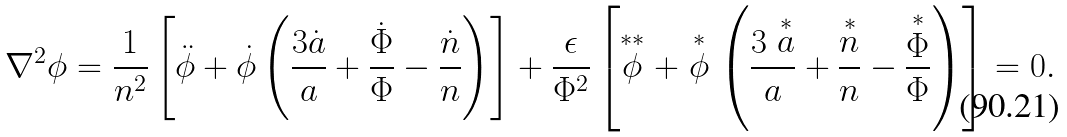Convert formula to latex. <formula><loc_0><loc_0><loc_500><loc_500>\nabla ^ { 2 } \phi = \frac { 1 } { n ^ { 2 } } \left [ \ddot { \phi } + \dot { \phi } \left ( \frac { 3 \dot { a } } { a } + \frac { \dot { \Phi } } { \Phi } - \frac { \dot { n } } { n } \right ) \right ] + \frac { \epsilon } { \Phi ^ { 2 } } \left [ \stackrel { \ast \ast } \phi + \stackrel { \ast } \phi \left ( \frac { 3 \stackrel { \ast } a } { a } + \frac { \stackrel { \ast } n } { n } - \frac { \stackrel { \ast } \Phi } { \Phi } \right ) \right ] = 0 .</formula> 